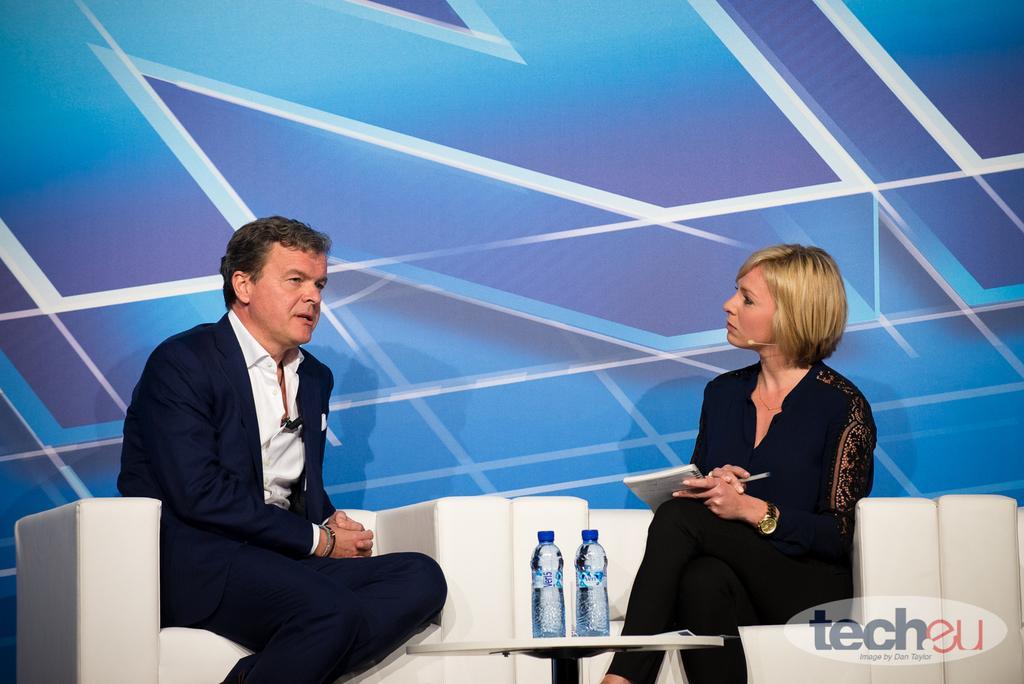Can you describe this image briefly? In this image I can see on the left side a man is sitting on the sofa and talking, he wore coat, trouser, shirt. In the middle there are water bottles on the table. On the right side there is a woman sitting on the sofa, she wore black color dress holding the book and pen in her hands. In the middle there is a blue color background in this image. 